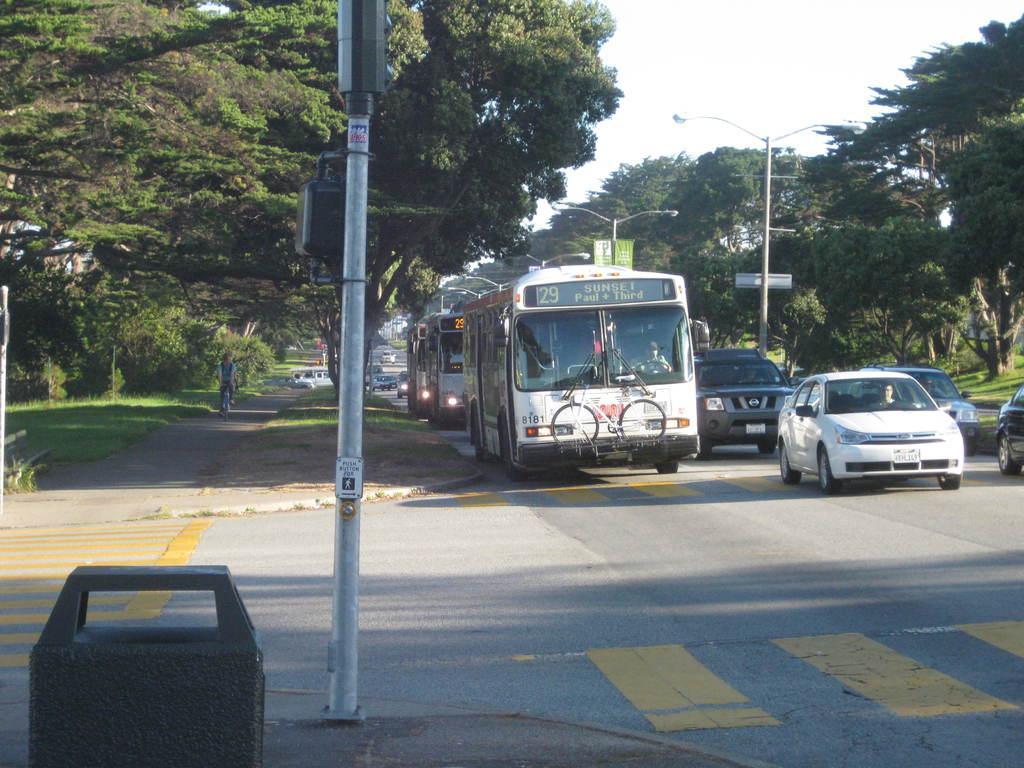Describe this image in one or two sentences. In this image I can see a road , on the road I can see the vehicles and I can see a bicycle attached to the bus on the road and I can see the sky and tree visible in the middle and I can see street light pole visible in front of the vehicles and on the left side I can see a person riding on bicycle visible on the left side. 